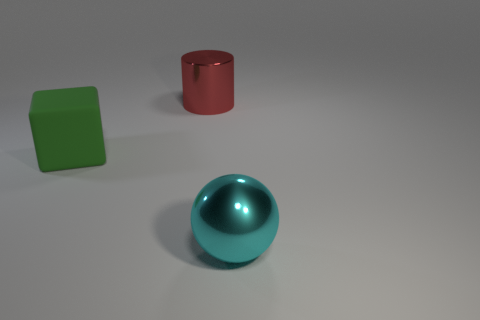Add 2 tiny yellow rubber cubes. How many objects exist? 5 Subtract all cubes. How many objects are left? 2 Subtract all red metal things. Subtract all large brown metallic spheres. How many objects are left? 2 Add 3 big green rubber blocks. How many big green rubber blocks are left? 4 Add 2 big cylinders. How many big cylinders exist? 3 Subtract 0 purple cylinders. How many objects are left? 3 